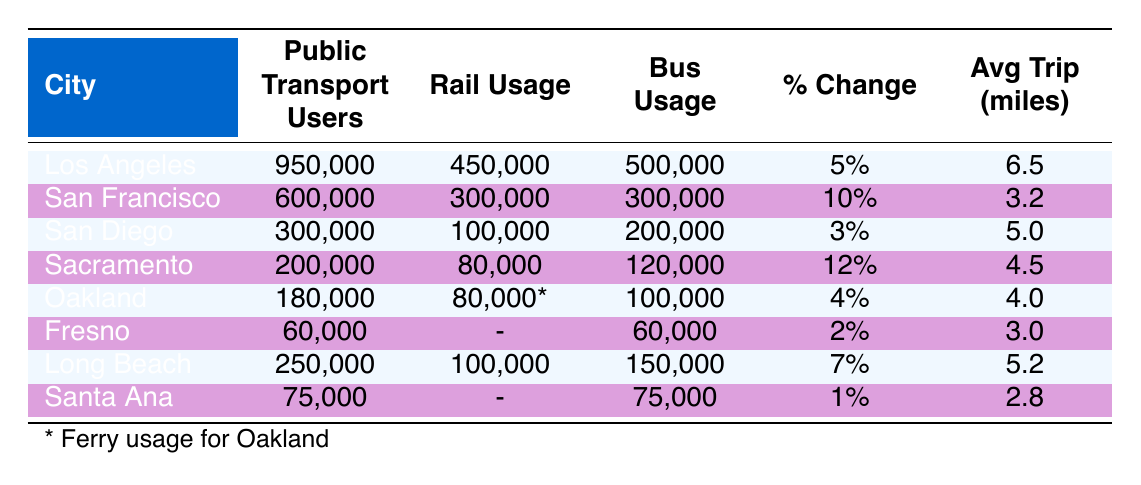What is the total number of public transport users in Los Angeles and San Francisco? To find the total number of public transport users in Los Angeles and San Francisco, we add the values from the table: Los Angeles has 950,000 users, and San Francisco has 600,000 users. Thus, the total is 950,000 + 600,000 = 1,550,000.
Answer: 1,550,000 Did Sacramento see the highest percentage change in public transportation users compared to the other cities? Sacramento has a percentage change of 12%, while the next highest percentage is 10% from San Francisco. So, Sacramento does have the highest percentage change.
Answer: Yes What city had the lowest average trip length and what was that length? The table shows that Santa Ana has the lowest average trip length at 2.8 miles.
Answer: 2.8 miles How many more bus users did Los Angeles have compared to San Diego? Los Angeles had 500,000 bus users, while San Diego had 200,000. To find the difference, we subtract: 500,000 - 200,000 = 300,000.
Answer: 300,000 What percentage change did Long Beach experience in public transport users from the previous year? Long Beach had a percentage change of 7% from the previous year, as indicated in the table.
Answer: 7% Which city had the highest subway usage in 2022? Upon reviewing the subway usage, Los Angeles had 450,000 subway users, which is the highest compared to San Francisco with 300,000.
Answer: Los Angeles What is the combined public transport usage for Sacramento and Oakland? Sacramento has 200,000 users and Oakland has 180,000 users. To find the combined usage, we add those numbers: 200,000 + 180,000 = 380,000.
Answer: 380,000 Is the average trip length longer for San Francisco compared to Sacramento? San Francisco has an average trip length of 3.2 miles, whereas Sacramento has 4.5 miles. Since 4.5 is greater than 3.2, the average trip length for Sacramento is longer.
Answer: No How much public transportation usage increased in San Diego from the previous year? San Diego had a percentage increase of 3%, which means its public transport user count improved from the previous year by that percentage. This is a specific value found directly in the table.
Answer: 3% 